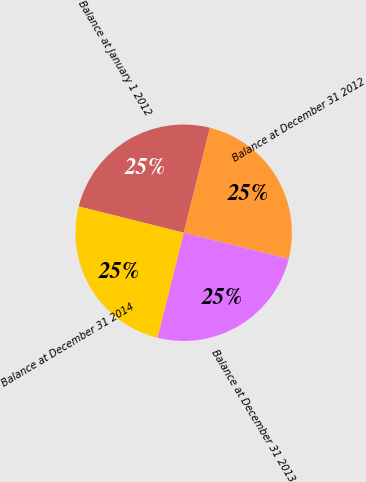<chart> <loc_0><loc_0><loc_500><loc_500><pie_chart><fcel>Balance at January 1 2012<fcel>Balance at December 31 2012<fcel>Balance at December 31 2013<fcel>Balance at December 31 2014<nl><fcel>24.99%<fcel>24.99%<fcel>25.0%<fcel>25.01%<nl></chart> 